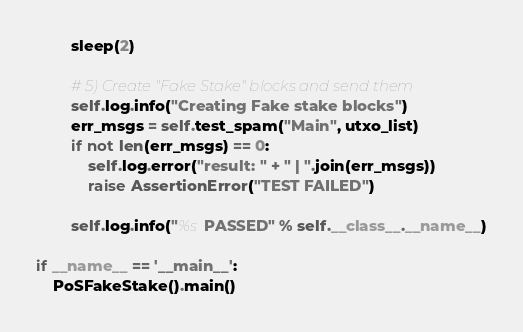Convert code to text. <code><loc_0><loc_0><loc_500><loc_500><_Python_>        sleep(2)

        # 5) Create "Fake Stake" blocks and send them
        self.log.info("Creating Fake stake blocks")
        err_msgs = self.test_spam("Main", utxo_list)
        if not len(err_msgs) == 0:
            self.log.error("result: " + " | ".join(err_msgs))
            raise AssertionError("TEST FAILED")

        self.log.info("%s PASSED" % self.__class__.__name__)

if __name__ == '__main__':
    PoSFakeStake().main()
</code> 